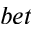Convert formula to latex. <formula><loc_0><loc_0><loc_500><loc_500>b e t</formula> 